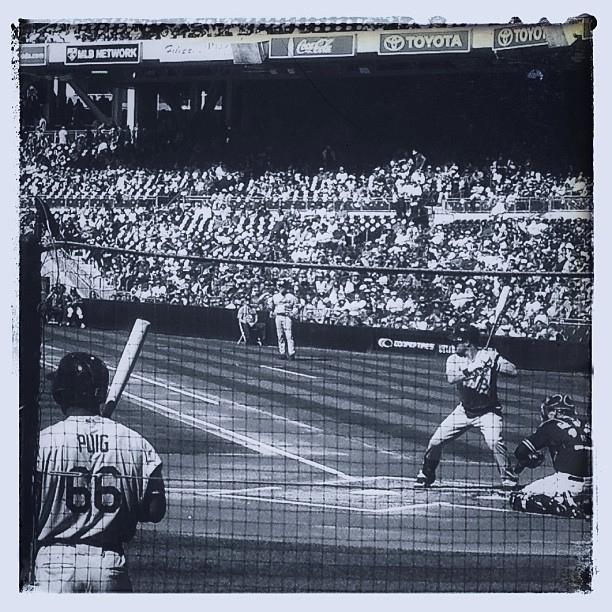How many people are there?
Give a very brief answer. 4. 